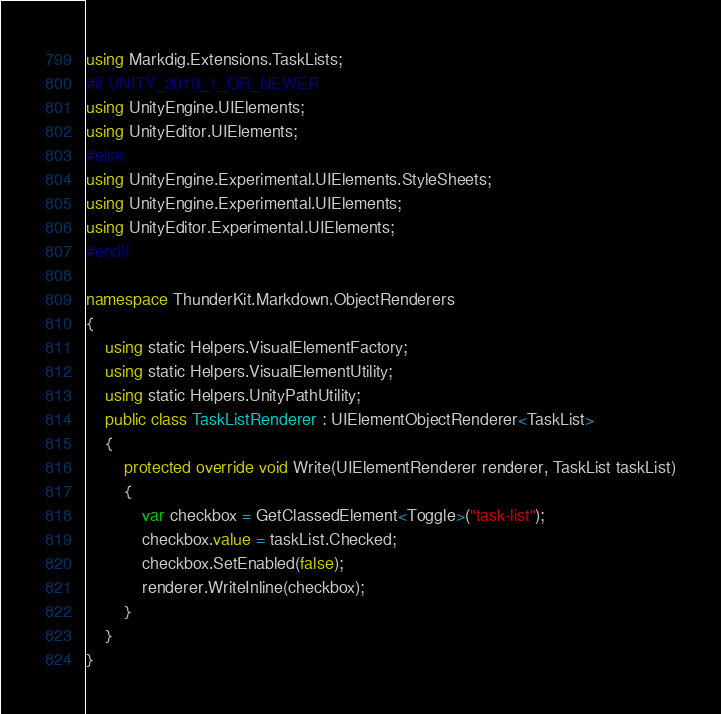<code> <loc_0><loc_0><loc_500><loc_500><_C#_>using Markdig.Extensions.TaskLists;
#if UNITY_2019_1_OR_NEWER
using UnityEngine.UIElements;
using UnityEditor.UIElements;
#else
using UnityEngine.Experimental.UIElements.StyleSheets;
using UnityEngine.Experimental.UIElements;
using UnityEditor.Experimental.UIElements;
#endif

namespace ThunderKit.Markdown.ObjectRenderers
{
    using static Helpers.VisualElementFactory;
    using static Helpers.VisualElementUtility;
    using static Helpers.UnityPathUtility;
    public class TaskListRenderer : UIElementObjectRenderer<TaskList>
    {
        protected override void Write(UIElementRenderer renderer, TaskList taskList)
        {
            var checkbox = GetClassedElement<Toggle>("task-list");
            checkbox.value = taskList.Checked;
            checkbox.SetEnabled(false);
            renderer.WriteInline(checkbox);
        }
    }
}
</code> 